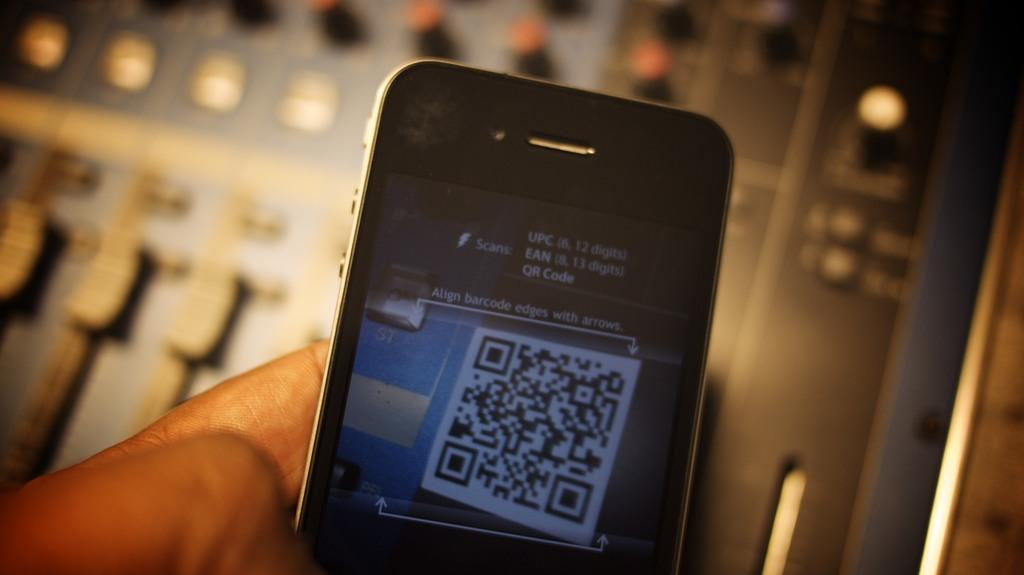<image>
Render a clear and concise summary of the photo. a phone that has scans written at the top 